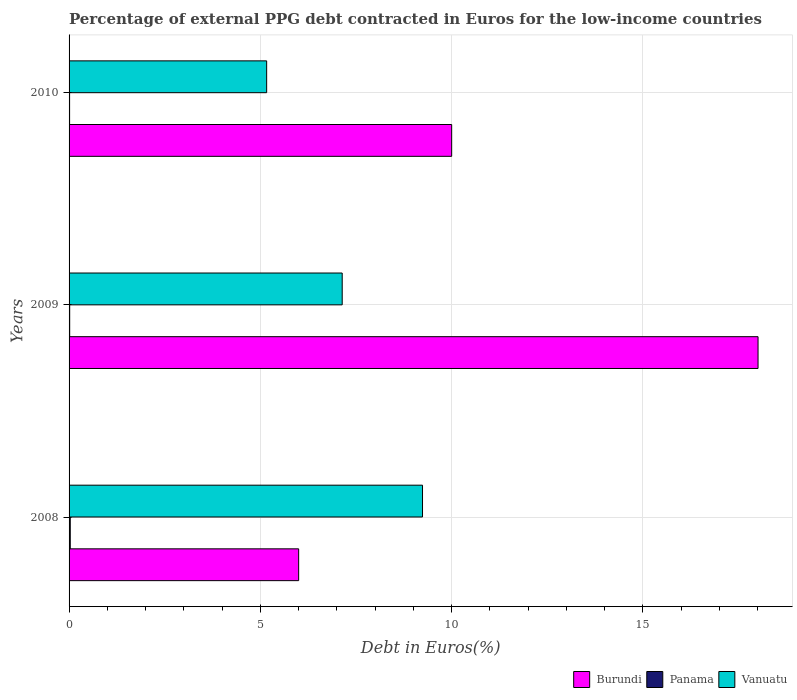How many different coloured bars are there?
Make the answer very short. 3. Are the number of bars per tick equal to the number of legend labels?
Provide a succinct answer. Yes. In how many cases, is the number of bars for a given year not equal to the number of legend labels?
Provide a short and direct response. 0. What is the percentage of external PPG debt contracted in Euros in Panama in 2009?
Provide a short and direct response. 0.02. Across all years, what is the maximum percentage of external PPG debt contracted in Euros in Vanuatu?
Keep it short and to the point. 9.24. Across all years, what is the minimum percentage of external PPG debt contracted in Euros in Panama?
Your response must be concise. 0.01. What is the total percentage of external PPG debt contracted in Euros in Panama in the graph?
Keep it short and to the point. 0.06. What is the difference between the percentage of external PPG debt contracted in Euros in Burundi in 2008 and that in 2009?
Your answer should be very brief. -12.01. What is the difference between the percentage of external PPG debt contracted in Euros in Burundi in 2010 and the percentage of external PPG debt contracted in Euros in Vanuatu in 2008?
Your answer should be compact. 0.76. What is the average percentage of external PPG debt contracted in Euros in Panama per year?
Your answer should be very brief. 0.02. In the year 2008, what is the difference between the percentage of external PPG debt contracted in Euros in Vanuatu and percentage of external PPG debt contracted in Euros in Panama?
Give a very brief answer. 9.21. In how many years, is the percentage of external PPG debt contracted in Euros in Vanuatu greater than 4 %?
Provide a short and direct response. 3. What is the ratio of the percentage of external PPG debt contracted in Euros in Panama in 2008 to that in 2009?
Offer a very short reply. 1.89. Is the difference between the percentage of external PPG debt contracted in Euros in Vanuatu in 2008 and 2009 greater than the difference between the percentage of external PPG debt contracted in Euros in Panama in 2008 and 2009?
Ensure brevity in your answer.  Yes. What is the difference between the highest and the second highest percentage of external PPG debt contracted in Euros in Panama?
Your response must be concise. 0.01. What is the difference between the highest and the lowest percentage of external PPG debt contracted in Euros in Vanuatu?
Your response must be concise. 4.07. In how many years, is the percentage of external PPG debt contracted in Euros in Vanuatu greater than the average percentage of external PPG debt contracted in Euros in Vanuatu taken over all years?
Make the answer very short. 1. What does the 3rd bar from the top in 2009 represents?
Provide a succinct answer. Burundi. What does the 3rd bar from the bottom in 2009 represents?
Your response must be concise. Vanuatu. How many bars are there?
Ensure brevity in your answer.  9. Are all the bars in the graph horizontal?
Offer a very short reply. Yes. How many years are there in the graph?
Your answer should be very brief. 3. What is the difference between two consecutive major ticks on the X-axis?
Provide a short and direct response. 5. Where does the legend appear in the graph?
Provide a succinct answer. Bottom right. How many legend labels are there?
Offer a terse response. 3. What is the title of the graph?
Your answer should be compact. Percentage of external PPG debt contracted in Euros for the low-income countries. Does "Europe(all income levels)" appear as one of the legend labels in the graph?
Give a very brief answer. No. What is the label or title of the X-axis?
Give a very brief answer. Debt in Euros(%). What is the Debt in Euros(%) of Burundi in 2008?
Provide a short and direct response. 6. What is the Debt in Euros(%) of Panama in 2008?
Provide a succinct answer. 0.03. What is the Debt in Euros(%) of Vanuatu in 2008?
Your answer should be very brief. 9.24. What is the Debt in Euros(%) in Burundi in 2009?
Your response must be concise. 18.01. What is the Debt in Euros(%) in Panama in 2009?
Offer a terse response. 0.02. What is the Debt in Euros(%) in Vanuatu in 2009?
Provide a short and direct response. 7.14. What is the Debt in Euros(%) in Burundi in 2010?
Your answer should be very brief. 10. What is the Debt in Euros(%) of Panama in 2010?
Your response must be concise. 0.01. What is the Debt in Euros(%) in Vanuatu in 2010?
Give a very brief answer. 5.16. Across all years, what is the maximum Debt in Euros(%) of Burundi?
Offer a terse response. 18.01. Across all years, what is the maximum Debt in Euros(%) of Panama?
Offer a very short reply. 0.03. Across all years, what is the maximum Debt in Euros(%) in Vanuatu?
Your answer should be very brief. 9.24. Across all years, what is the minimum Debt in Euros(%) in Burundi?
Provide a short and direct response. 6. Across all years, what is the minimum Debt in Euros(%) of Panama?
Provide a short and direct response. 0.01. Across all years, what is the minimum Debt in Euros(%) of Vanuatu?
Ensure brevity in your answer.  5.16. What is the total Debt in Euros(%) of Burundi in the graph?
Keep it short and to the point. 34.01. What is the total Debt in Euros(%) in Panama in the graph?
Your answer should be very brief. 0.06. What is the total Debt in Euros(%) in Vanuatu in the graph?
Provide a succinct answer. 21.54. What is the difference between the Debt in Euros(%) of Burundi in 2008 and that in 2009?
Give a very brief answer. -12.01. What is the difference between the Debt in Euros(%) of Panama in 2008 and that in 2009?
Your response must be concise. 0.01. What is the difference between the Debt in Euros(%) of Vanuatu in 2008 and that in 2009?
Ensure brevity in your answer.  2.1. What is the difference between the Debt in Euros(%) in Burundi in 2008 and that in 2010?
Provide a short and direct response. -4. What is the difference between the Debt in Euros(%) in Panama in 2008 and that in 2010?
Keep it short and to the point. 0.02. What is the difference between the Debt in Euros(%) in Vanuatu in 2008 and that in 2010?
Your response must be concise. 4.07. What is the difference between the Debt in Euros(%) of Burundi in 2009 and that in 2010?
Provide a short and direct response. 8.01. What is the difference between the Debt in Euros(%) in Panama in 2009 and that in 2010?
Your answer should be compact. 0. What is the difference between the Debt in Euros(%) of Vanuatu in 2009 and that in 2010?
Provide a succinct answer. 1.97. What is the difference between the Debt in Euros(%) of Burundi in 2008 and the Debt in Euros(%) of Panama in 2009?
Offer a very short reply. 5.98. What is the difference between the Debt in Euros(%) in Burundi in 2008 and the Debt in Euros(%) in Vanuatu in 2009?
Keep it short and to the point. -1.14. What is the difference between the Debt in Euros(%) of Panama in 2008 and the Debt in Euros(%) of Vanuatu in 2009?
Your answer should be very brief. -7.11. What is the difference between the Debt in Euros(%) in Burundi in 2008 and the Debt in Euros(%) in Panama in 2010?
Your answer should be very brief. 5.99. What is the difference between the Debt in Euros(%) of Burundi in 2008 and the Debt in Euros(%) of Vanuatu in 2010?
Make the answer very short. 0.84. What is the difference between the Debt in Euros(%) in Panama in 2008 and the Debt in Euros(%) in Vanuatu in 2010?
Your response must be concise. -5.13. What is the difference between the Debt in Euros(%) in Burundi in 2009 and the Debt in Euros(%) in Panama in 2010?
Make the answer very short. 17.99. What is the difference between the Debt in Euros(%) of Burundi in 2009 and the Debt in Euros(%) of Vanuatu in 2010?
Keep it short and to the point. 12.84. What is the difference between the Debt in Euros(%) in Panama in 2009 and the Debt in Euros(%) in Vanuatu in 2010?
Provide a succinct answer. -5.15. What is the average Debt in Euros(%) of Burundi per year?
Provide a short and direct response. 11.34. What is the average Debt in Euros(%) of Panama per year?
Provide a succinct answer. 0.02. What is the average Debt in Euros(%) of Vanuatu per year?
Ensure brevity in your answer.  7.18. In the year 2008, what is the difference between the Debt in Euros(%) of Burundi and Debt in Euros(%) of Panama?
Make the answer very short. 5.97. In the year 2008, what is the difference between the Debt in Euros(%) in Burundi and Debt in Euros(%) in Vanuatu?
Give a very brief answer. -3.24. In the year 2008, what is the difference between the Debt in Euros(%) of Panama and Debt in Euros(%) of Vanuatu?
Your response must be concise. -9.21. In the year 2009, what is the difference between the Debt in Euros(%) of Burundi and Debt in Euros(%) of Panama?
Give a very brief answer. 17.99. In the year 2009, what is the difference between the Debt in Euros(%) in Burundi and Debt in Euros(%) in Vanuatu?
Your response must be concise. 10.87. In the year 2009, what is the difference between the Debt in Euros(%) in Panama and Debt in Euros(%) in Vanuatu?
Provide a short and direct response. -7.12. In the year 2010, what is the difference between the Debt in Euros(%) of Burundi and Debt in Euros(%) of Panama?
Offer a very short reply. 9.99. In the year 2010, what is the difference between the Debt in Euros(%) in Burundi and Debt in Euros(%) in Vanuatu?
Your response must be concise. 4.84. In the year 2010, what is the difference between the Debt in Euros(%) of Panama and Debt in Euros(%) of Vanuatu?
Ensure brevity in your answer.  -5.15. What is the ratio of the Debt in Euros(%) of Burundi in 2008 to that in 2009?
Your response must be concise. 0.33. What is the ratio of the Debt in Euros(%) in Panama in 2008 to that in 2009?
Your answer should be very brief. 1.89. What is the ratio of the Debt in Euros(%) in Vanuatu in 2008 to that in 2009?
Ensure brevity in your answer.  1.29. What is the ratio of the Debt in Euros(%) in Panama in 2008 to that in 2010?
Keep it short and to the point. 2.23. What is the ratio of the Debt in Euros(%) of Vanuatu in 2008 to that in 2010?
Your answer should be compact. 1.79. What is the ratio of the Debt in Euros(%) of Burundi in 2009 to that in 2010?
Your answer should be compact. 1.8. What is the ratio of the Debt in Euros(%) in Panama in 2009 to that in 2010?
Your answer should be very brief. 1.18. What is the ratio of the Debt in Euros(%) of Vanuatu in 2009 to that in 2010?
Your answer should be compact. 1.38. What is the difference between the highest and the second highest Debt in Euros(%) of Burundi?
Offer a terse response. 8.01. What is the difference between the highest and the second highest Debt in Euros(%) in Panama?
Your answer should be compact. 0.01. What is the difference between the highest and the second highest Debt in Euros(%) in Vanuatu?
Your answer should be compact. 2.1. What is the difference between the highest and the lowest Debt in Euros(%) of Burundi?
Provide a short and direct response. 12.01. What is the difference between the highest and the lowest Debt in Euros(%) of Panama?
Ensure brevity in your answer.  0.02. What is the difference between the highest and the lowest Debt in Euros(%) of Vanuatu?
Your answer should be compact. 4.07. 